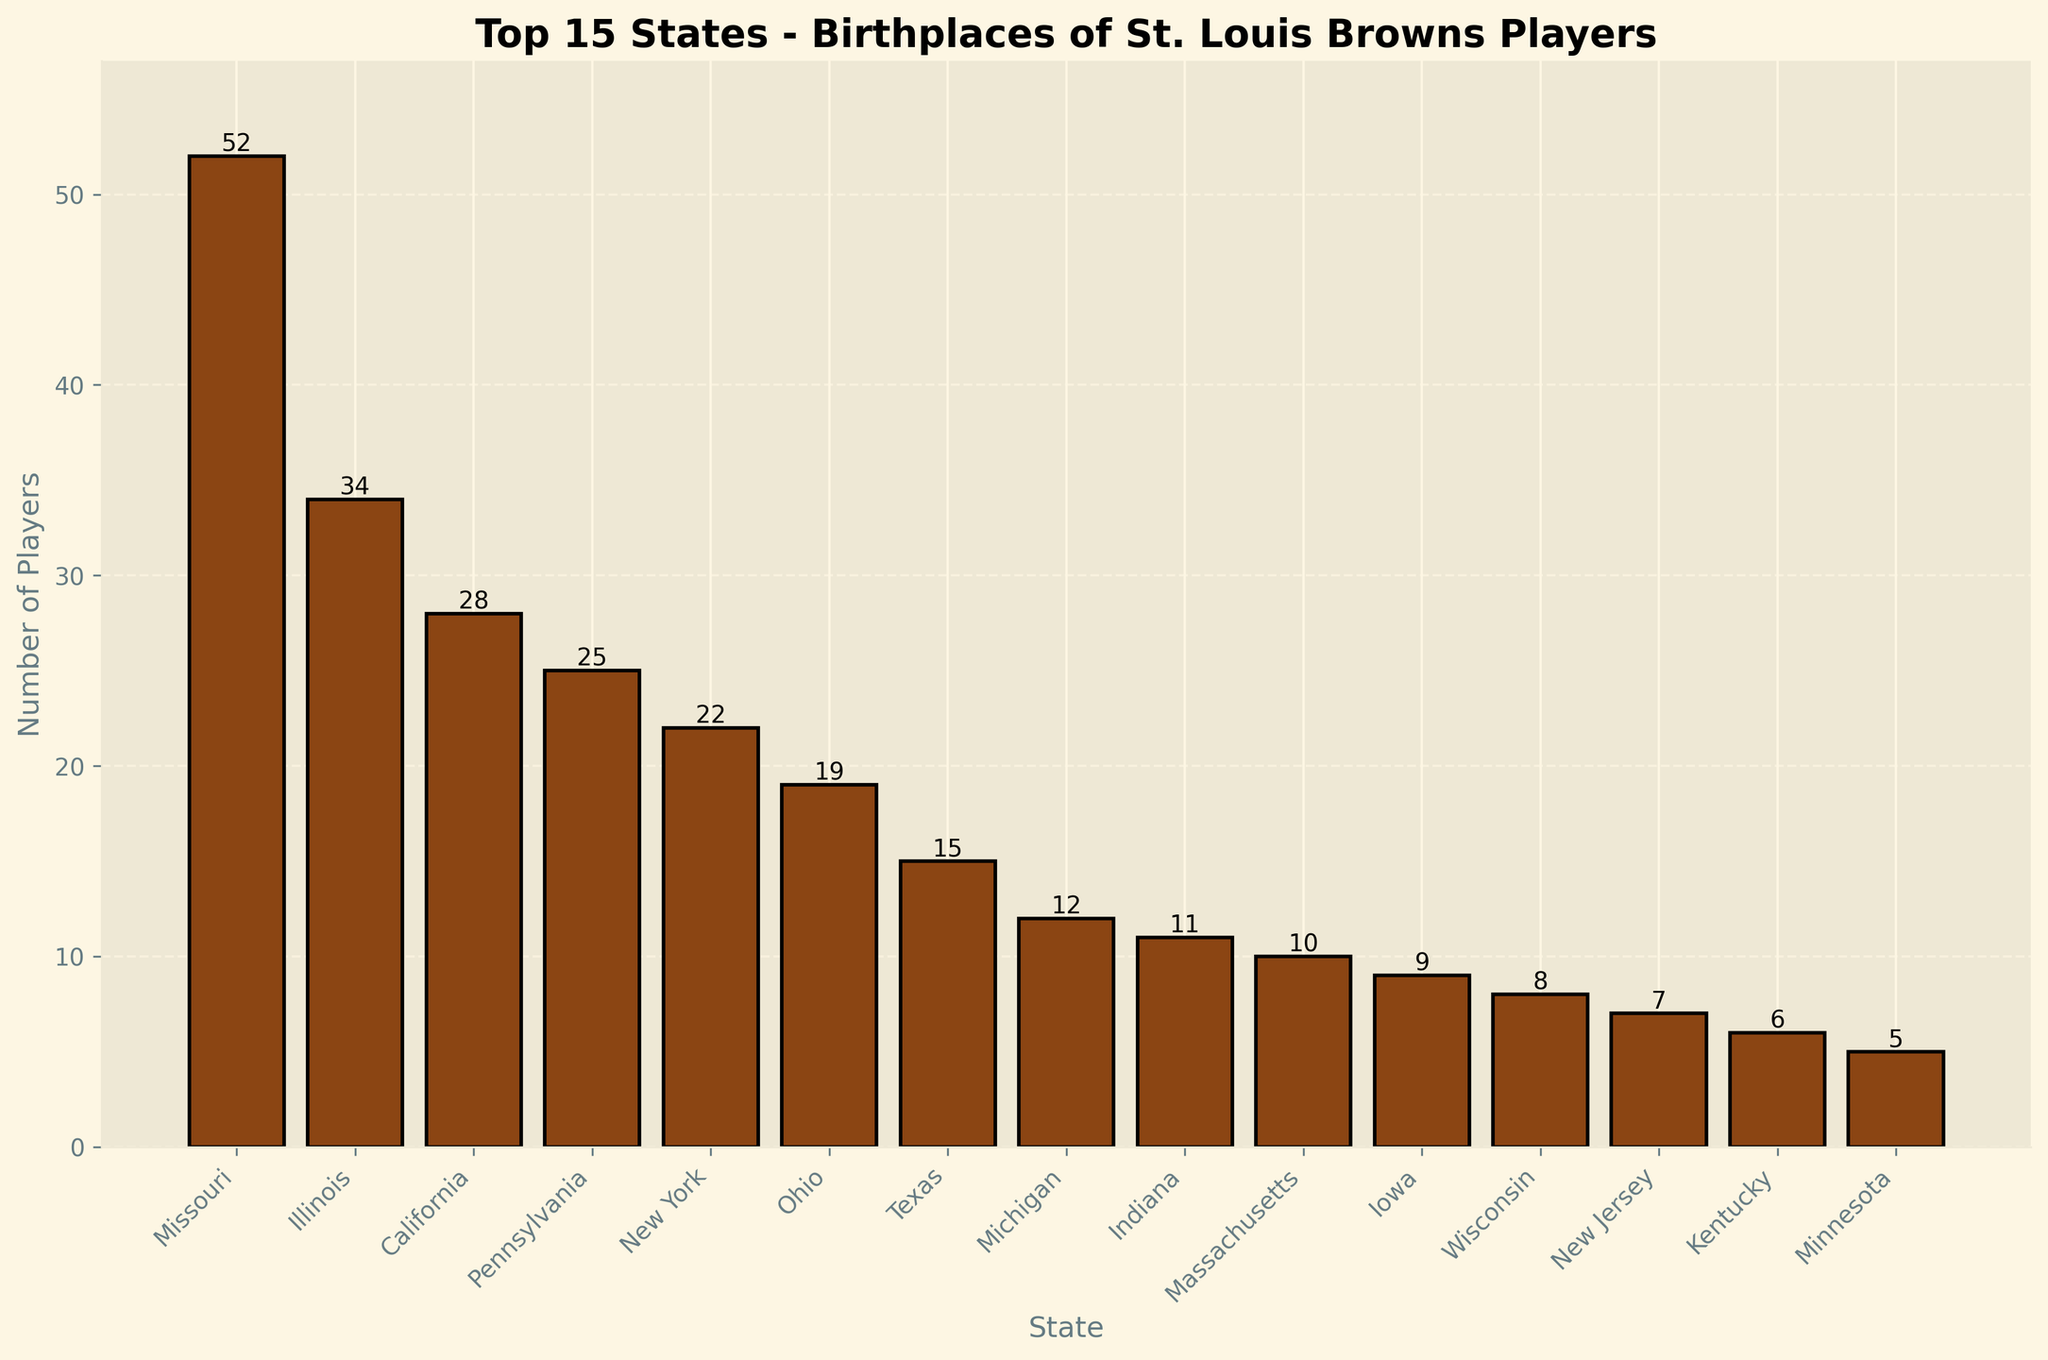What's the state with the highest number of St. Louis Browns players born in it? The tallest bar on the plot represents the state with the highest number of players. Missouri has the tallest bar.
Answer: Missouri Which state has more St. Louis Browns players, Illinois or Texas? By comparing the heights of the bars for Illinois and Texas, the bar for Illinois is taller.
Answer: Illinois How many players were born in the top 3 states combined? The number of players in Missouri (52), Illinois (34), and California (28) should be summed up: 52 + 34 + 28.
Answer: 114 How many states have fewer than 10 players born in them among the top 15? By looking at the bars and counting those with a height less than 10, states Indiana, Massachusetts, Iowa, Wisconsin, New Jersey, and Kentucky have fewer than 10 players each.
Answer: 6 Which state has exactly 25 players born in it? The bar corresponding to Pennsylvania reaches the height of 25.
Answer: Pennsylvania How many more players were born in Missouri than in Ohio? The difference between the number of players in Missouri (52) and Ohio (19) is calculated: 52 - 19.
Answer: 33 What is the average number of players born in the top 5 states? Add up the number of players in Missouri (52), Illinois (34), California (28), Pennsylvania (25), and New York (22), then divide by 5: (52 + 34 + 28 + 25 + 22) / 5.
Answer: 32.2 Which has fewer players: Indiana or New Jersey? Comparing the heights of the bars for Indiana (11) and New Jersey (7), New Jersey has fewer players.
Answer: New Jersey What's the combined number of players born in Indiana, Massachusetts, and Iowa? Sum the number of players in these states: Indiana (11), Massachusetts (10), and Iowa (9): 11 + 10 + 9.
Answer: 30 How many more players does Massachusetts have compared to Minnesota? The difference in the number of players between Massachusetts (10) and Minnesota (5) is 10 - 5.
Answer: 5 